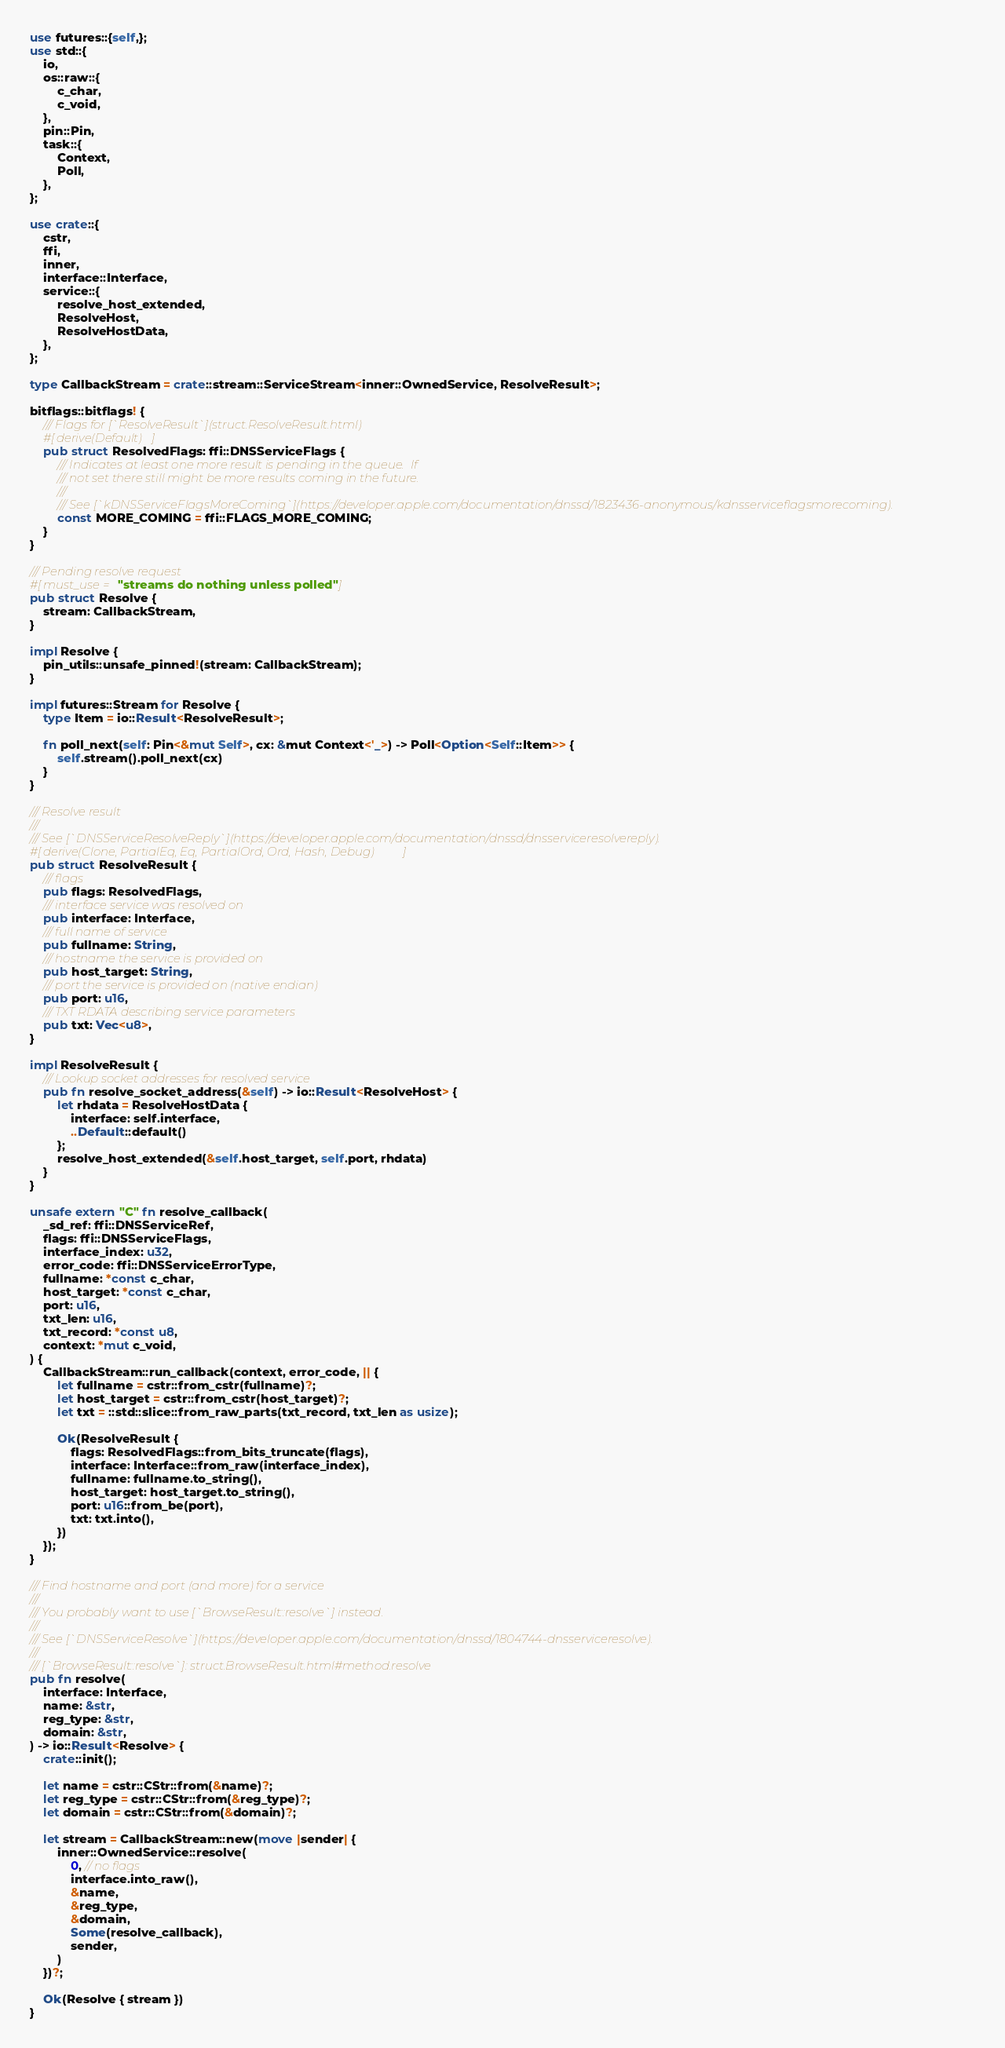Convert code to text. <code><loc_0><loc_0><loc_500><loc_500><_Rust_>use futures::{self,};
use std::{
	io,
	os::raw::{
		c_char,
		c_void,
	},
	pin::Pin,
	task::{
		Context,
		Poll,
	},
};

use crate::{
	cstr,
	ffi,
	inner,
	interface::Interface,
	service::{
		resolve_host_extended,
		ResolveHost,
		ResolveHostData,
	},
};

type CallbackStream = crate::stream::ServiceStream<inner::OwnedService, ResolveResult>;

bitflags::bitflags! {
	/// Flags for [`ResolveResult`](struct.ResolveResult.html)
	#[derive(Default)]
	pub struct ResolvedFlags: ffi::DNSServiceFlags {
		/// Indicates at least one more result is pending in the queue.  If
		/// not set there still might be more results coming in the future.
		///
		/// See [`kDNSServiceFlagsMoreComing`](https://developer.apple.com/documentation/dnssd/1823436-anonymous/kdnsserviceflagsmorecoming).
		const MORE_COMING = ffi::FLAGS_MORE_COMING;
	}
}

/// Pending resolve request
#[must_use = "streams do nothing unless polled"]
pub struct Resolve {
	stream: CallbackStream,
}

impl Resolve {
	pin_utils::unsafe_pinned!(stream: CallbackStream);
}

impl futures::Stream for Resolve {
	type Item = io::Result<ResolveResult>;

	fn poll_next(self: Pin<&mut Self>, cx: &mut Context<'_>) -> Poll<Option<Self::Item>> {
		self.stream().poll_next(cx)
	}
}

/// Resolve result
///
/// See [`DNSServiceResolveReply`](https://developer.apple.com/documentation/dnssd/dnsserviceresolvereply).
#[derive(Clone, PartialEq, Eq, PartialOrd, Ord, Hash, Debug)]
pub struct ResolveResult {
	/// flags
	pub flags: ResolvedFlags,
	/// interface service was resolved on
	pub interface: Interface,
	/// full name of service
	pub fullname: String,
	/// hostname the service is provided on
	pub host_target: String,
	/// port the service is provided on (native endian)
	pub port: u16,
	/// TXT RDATA describing service parameters
	pub txt: Vec<u8>,
}

impl ResolveResult {
	/// Lookup socket addresses for resolved service
	pub fn resolve_socket_address(&self) -> io::Result<ResolveHost> {
		let rhdata = ResolveHostData {
			interface: self.interface,
			..Default::default()
		};
		resolve_host_extended(&self.host_target, self.port, rhdata)
	}
}

unsafe extern "C" fn resolve_callback(
	_sd_ref: ffi::DNSServiceRef,
	flags: ffi::DNSServiceFlags,
	interface_index: u32,
	error_code: ffi::DNSServiceErrorType,
	fullname: *const c_char,
	host_target: *const c_char,
	port: u16,
	txt_len: u16,
	txt_record: *const u8,
	context: *mut c_void,
) {
	CallbackStream::run_callback(context, error_code, || {
		let fullname = cstr::from_cstr(fullname)?;
		let host_target = cstr::from_cstr(host_target)?;
		let txt = ::std::slice::from_raw_parts(txt_record, txt_len as usize);

		Ok(ResolveResult {
			flags: ResolvedFlags::from_bits_truncate(flags),
			interface: Interface::from_raw(interface_index),
			fullname: fullname.to_string(),
			host_target: host_target.to_string(),
			port: u16::from_be(port),
			txt: txt.into(),
		})
	});
}

/// Find hostname and port (and more) for a service
///
/// You probably want to use [`BrowseResult::resolve`] instead.
///
/// See [`DNSServiceResolve`](https://developer.apple.com/documentation/dnssd/1804744-dnsserviceresolve).
///
/// [`BrowseResult::resolve`]: struct.BrowseResult.html#method.resolve
pub fn resolve(
	interface: Interface,
	name: &str,
	reg_type: &str,
	domain: &str,
) -> io::Result<Resolve> {
	crate::init();

	let name = cstr::CStr::from(&name)?;
	let reg_type = cstr::CStr::from(&reg_type)?;
	let domain = cstr::CStr::from(&domain)?;

	let stream = CallbackStream::new(move |sender| {
		inner::OwnedService::resolve(
			0, // no flags
			interface.into_raw(),
			&name,
			&reg_type,
			&domain,
			Some(resolve_callback),
			sender,
		)
	})?;

	Ok(Resolve { stream })
}
</code> 